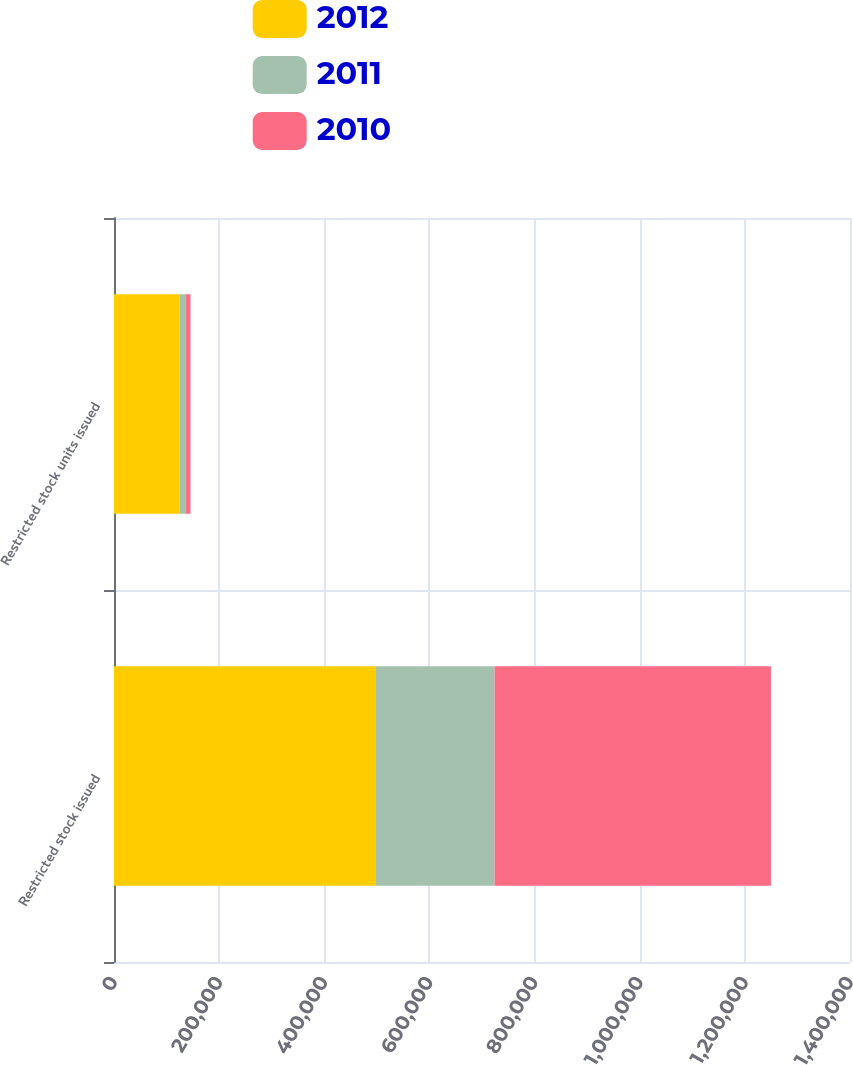Convert chart. <chart><loc_0><loc_0><loc_500><loc_500><stacked_bar_chart><ecel><fcel>Restricted stock issued<fcel>Restricted stock units issued<nl><fcel>2012<fcel>497100<fcel>124450<nl><fcel>2011<fcel>226850<fcel>12100<nl><fcel>2010<fcel>525600<fcel>9000<nl></chart> 